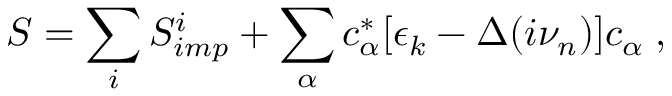<formula> <loc_0><loc_0><loc_500><loc_500>S = \sum _ { i } S _ { i m p } ^ { i } + \sum _ { \alpha } c _ { \alpha } ^ { * } [ \epsilon _ { k } - \Delta ( i \nu _ { n } ) ] c _ { \alpha } \, ,</formula> 